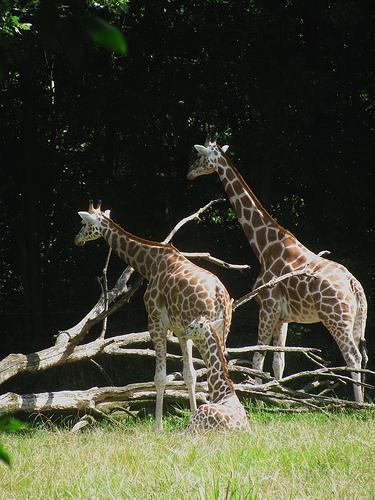How many giraffes are shown?
Give a very brief answer. 3. How many giraffes are standing?
Give a very brief answer. 2. How many giraffes are sitting?
Give a very brief answer. 1. 